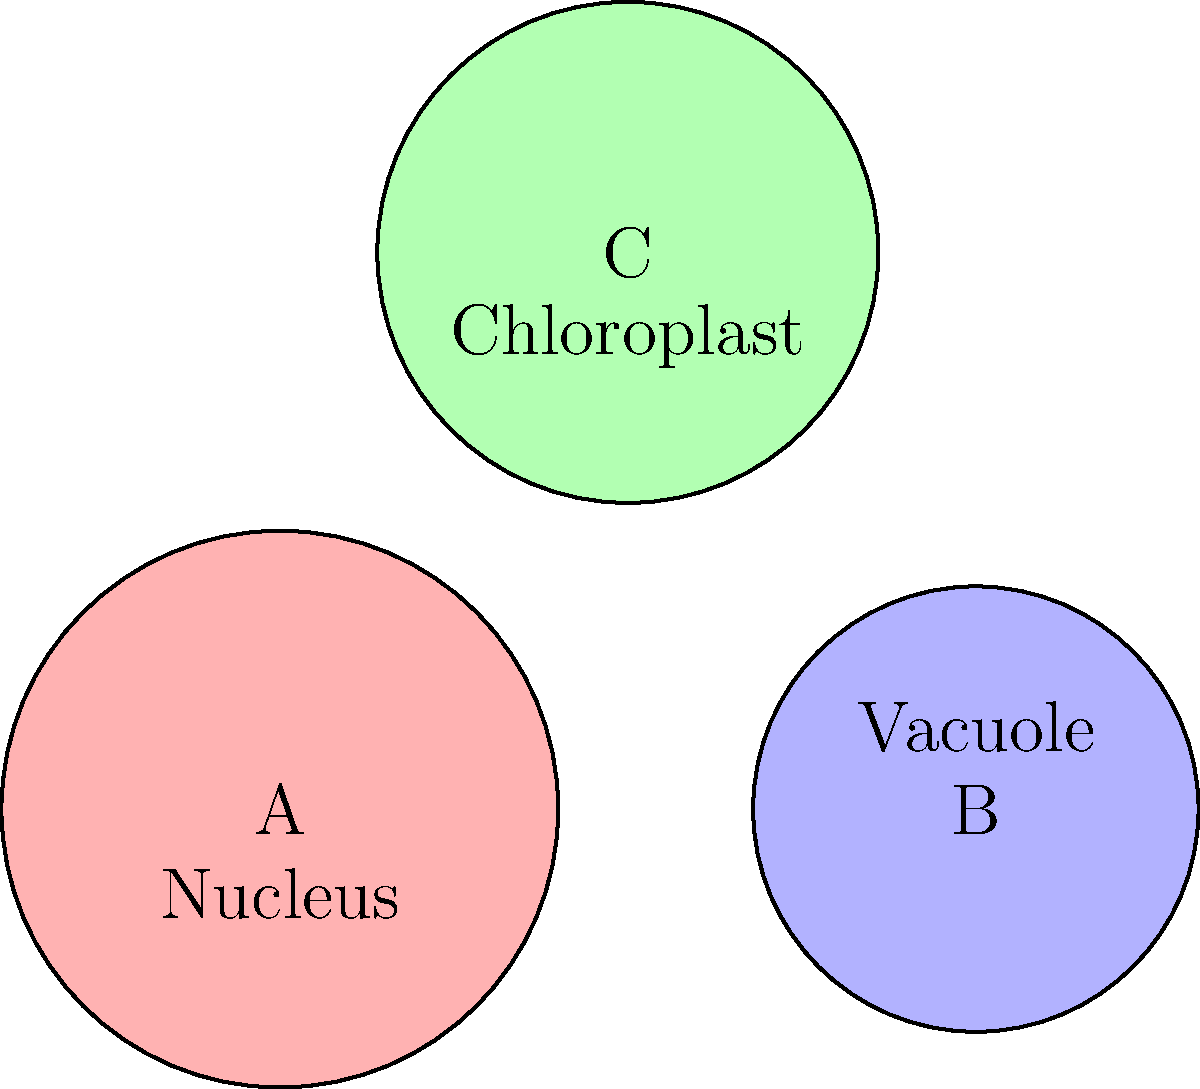Based on the microscopic images of cells A, B, and C, which cell type is most likely to be a plant cell, and what key feature supports this classification? Let's analyze each cell type step-by-step:

1. Cell A:
   - Large, centrally located structure labeled "Nucleus"
   - No other distinctive features visible
   - Consistent with animal or plant cells

2. Cell B:
   - Smaller overall size
   - Large structure labeled "Vacuole"
   - Vacuoles are present in both plant and animal cells, but plant cells typically have larger, more prominent vacuoles

3. Cell C:
   - Medium-sized cell
   - Contains structures labeled "Chloroplast"
   - Chloroplasts are unique to plant cells and some algae, as they are the site of photosynthesis

Key features for plant cell identification:
- Presence of a cell wall (not visible in this image)
- Large central vacuole
- Chloroplasts

Among the three cells, Cell C is the only one with a feature exclusive to plant cells: chloroplasts. While Cell B has a large vacuole which is characteristic of plant cells, it's not a definitive feature. The presence of chloroplasts in Cell C is a clear indicator that it is a plant cell.
Answer: Cell C; presence of chloroplasts 